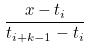<formula> <loc_0><loc_0><loc_500><loc_500>\frac { x - t _ { i } } { t _ { i + k - 1 } - t _ { i } }</formula> 